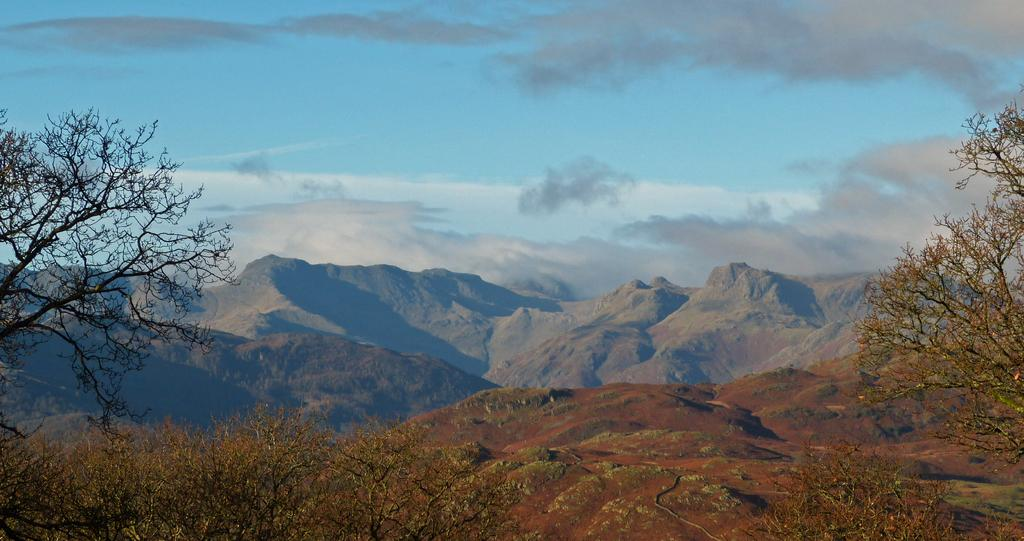What type of vegetation can be seen in the image? There are trees in the image. What geographical feature is visible in the background? There are mountains in the image. What is visible in the sky at the top of the image? There are clouds in the sky at the top of the image. What type of pear can be seen in the jar on the mountain in the image? There is no pear or jar present in the image; it features trees, mountains, and clouds. How does the sail on the mountain help the trees in the image? There is no sail or any sail-related activity present in the image. 